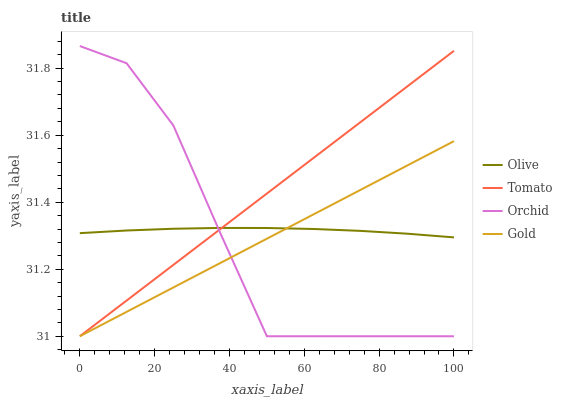Does Orchid have the minimum area under the curve?
Answer yes or no. Yes. Does Tomato have the maximum area under the curve?
Answer yes or no. Yes. Does Gold have the minimum area under the curve?
Answer yes or no. No. Does Gold have the maximum area under the curve?
Answer yes or no. No. Is Gold the smoothest?
Answer yes or no. Yes. Is Orchid the roughest?
Answer yes or no. Yes. Is Tomato the smoothest?
Answer yes or no. No. Is Tomato the roughest?
Answer yes or no. No. Does Tomato have the highest value?
Answer yes or no. No. 